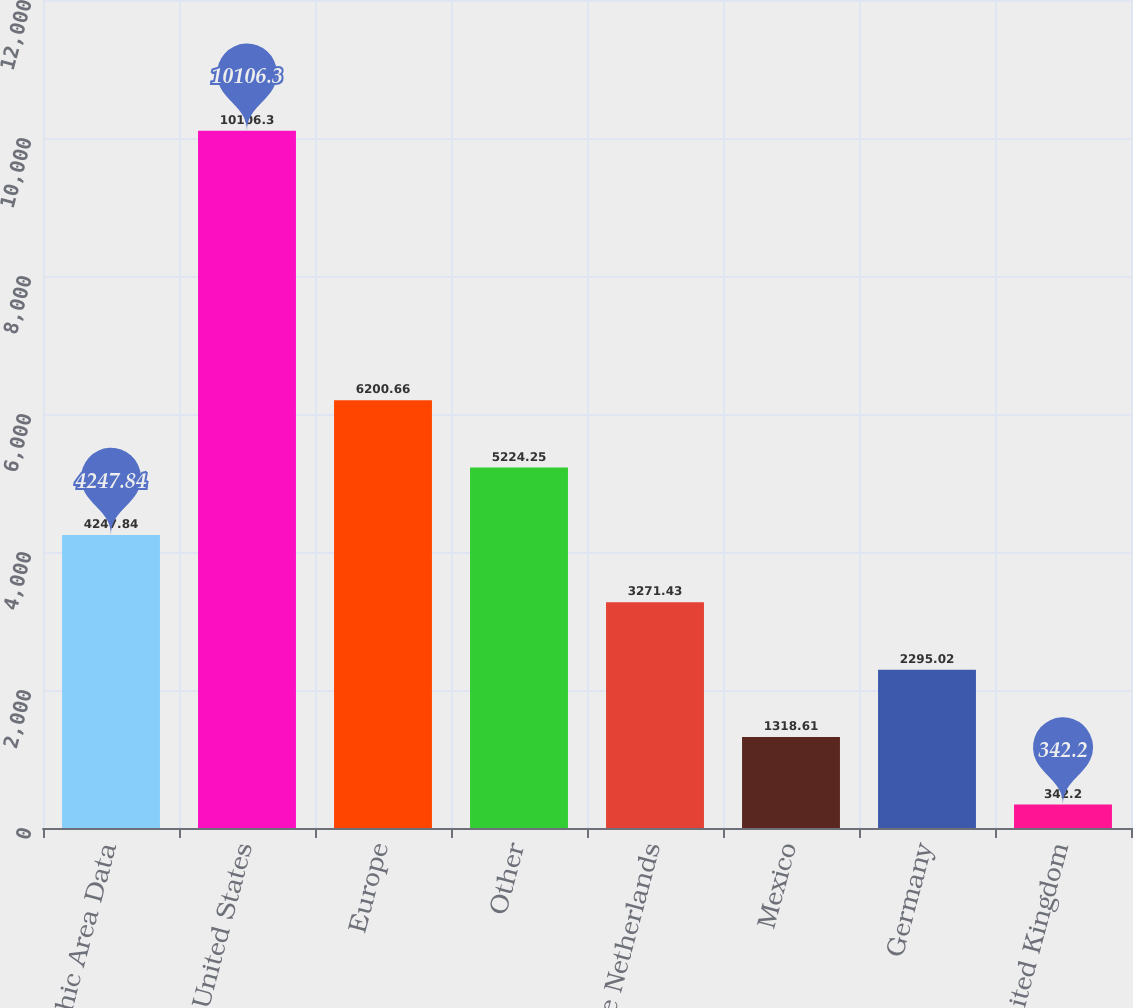Convert chart to OTSL. <chart><loc_0><loc_0><loc_500><loc_500><bar_chart><fcel>Geographic Area Data<fcel>United States<fcel>Europe<fcel>Other<fcel>The Netherlands<fcel>Mexico<fcel>Germany<fcel>United Kingdom<nl><fcel>4247.84<fcel>10106.3<fcel>6200.66<fcel>5224.25<fcel>3271.43<fcel>1318.61<fcel>2295.02<fcel>342.2<nl></chart> 